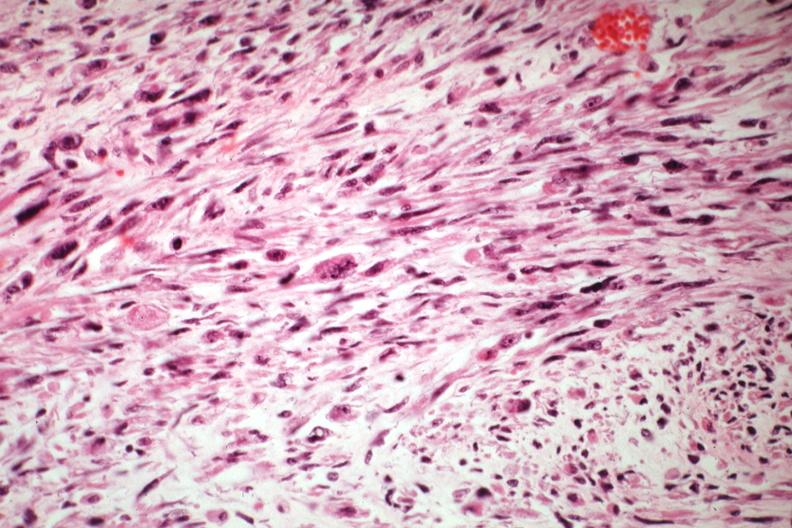what is present?
Answer the question using a single word or phrase. Uterus 